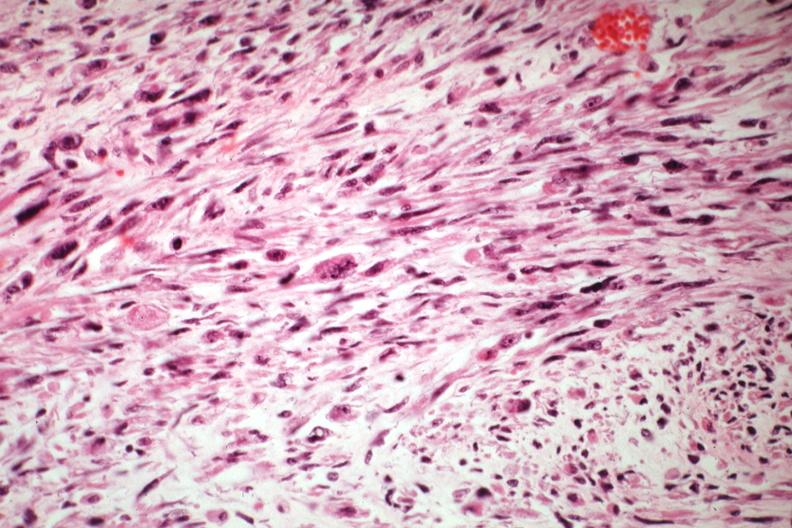what is present?
Answer the question using a single word or phrase. Uterus 